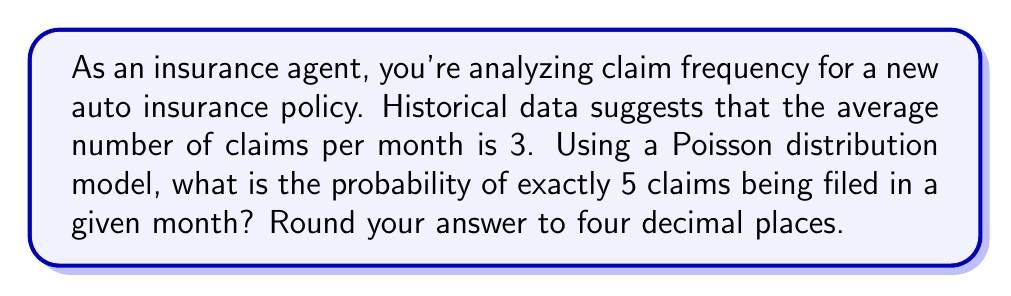What is the answer to this math problem? Let's approach this step-by-step using the Poisson distribution formula:

1) The Poisson distribution is given by:

   $$P(X = k) = \frac{e^{-\lambda} \lambda^k}{k!}$$

   Where:
   - $\lambda$ is the average number of events in the given interval
   - $k$ is the number of events we're calculating the probability for
   - $e$ is Euler's number (approximately 2.71828)

2) In this case:
   - $\lambda = 3$ (average number of claims per month)
   - $k = 5$ (we're calculating the probability of exactly 5 claims)

3) Let's substitute these values into the formula:

   $$P(X = 5) = \frac{e^{-3} 3^5}{5!}$$

4) Now, let's calculate each part:
   - $e^{-3} \approx 0.0497871$
   - $3^5 = 243$
   - $5! = 5 \times 4 \times 3 \times 2 \times 1 = 120$

5) Substituting these values:

   $$P(X = 5) = \frac{0.0497871 \times 243}{120}$$

6) Calculating this:

   $$P(X = 5) \approx 0.1008$$

7) Rounding to four decimal places:

   $$P(X = 5) \approx 0.1008$$

This means there's about a 10.08% chance of exactly 5 claims being filed in a given month.
Answer: 0.1008 